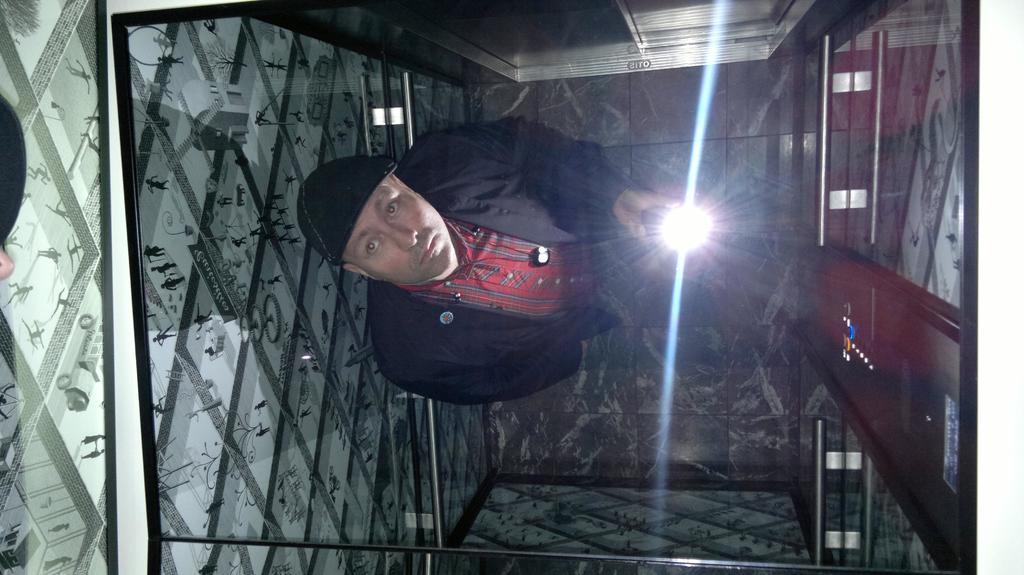Describe this image in one or two sentences. In the image we can see a man wearing clothes, cap and holding the torch in hand. 